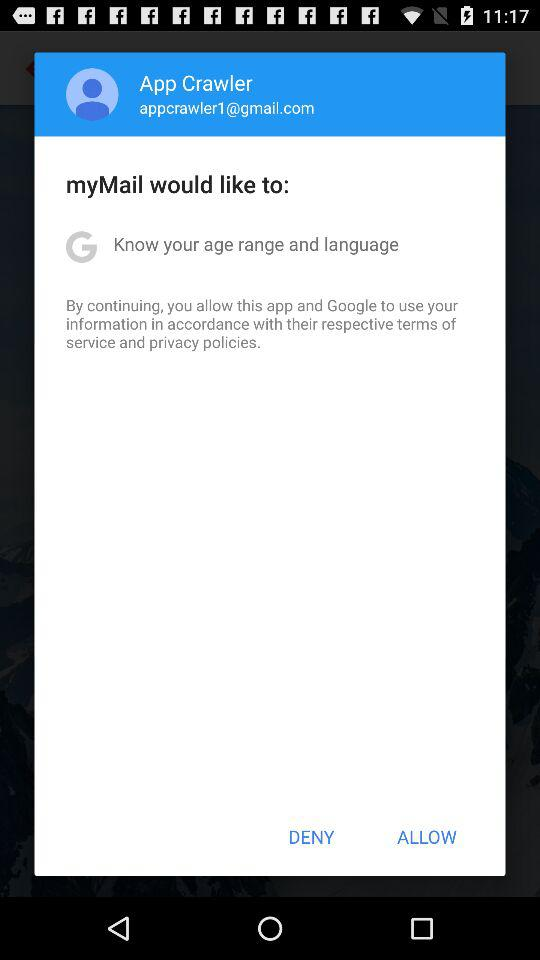What is the email ID of the user? The email ID is appcrawler1@gmail.com. 